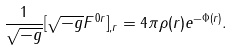<formula> <loc_0><loc_0><loc_500><loc_500>\frac { 1 } { \sqrt { - g } } [ \sqrt { - g } F ^ { 0 r } ] _ { , r } = 4 \pi \rho ( r ) e ^ { - \Phi ( r ) } .</formula> 